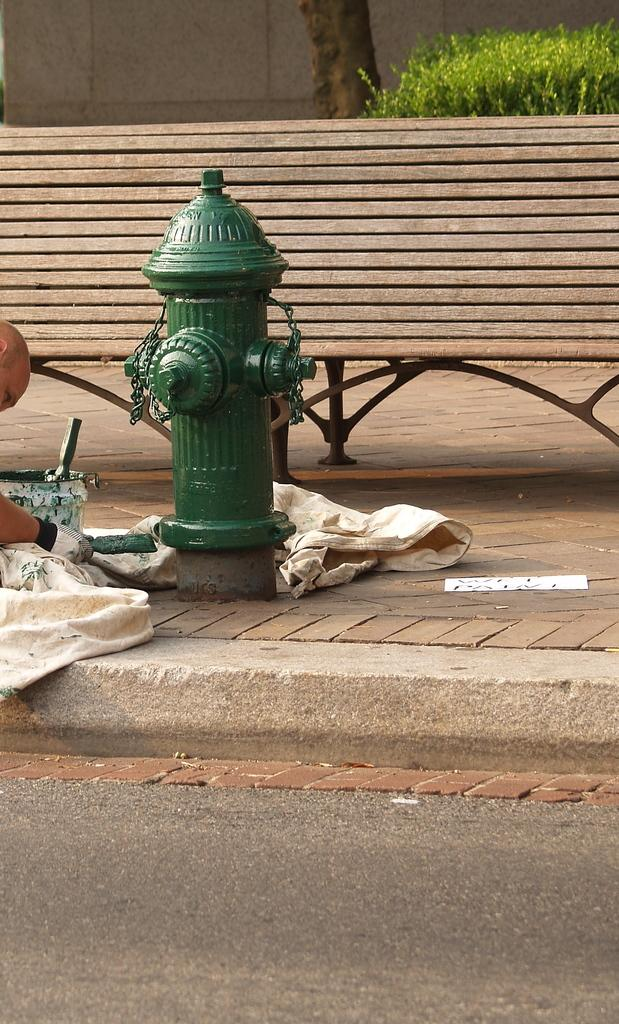What is the main subject of the image? There is a person in the image. What type of material can be seen in the image? There is cloth in the image. What is located on the path in the image? There is an object on the path in the image. What type of vegetation is present in the image? There is a plant in the image. What type of seating is visible in the image? There is a bench in the image. What type of structure is present in the image? There is a wall in the image. What type of surface is visible in the image? There is a road in the image. What type of natural element is present in the image? There is the bark of a tree in the image. What grade does the amusement park receive in the image? There is no amusement park present in the image, so it is not possible to determine a grade. What type of vase is visible on the bench in the image? There is no vase present on the bench in the image. 